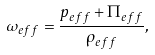<formula> <loc_0><loc_0><loc_500><loc_500>\omega _ { e f f } = \frac { p _ { e f f } + \Pi _ { e f f } } { \rho _ { e f f } } ,</formula> 